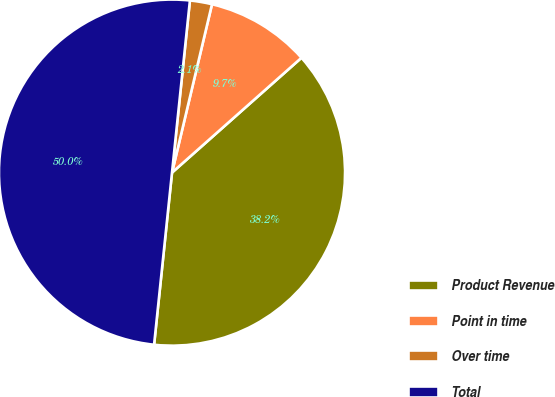Convert chart. <chart><loc_0><loc_0><loc_500><loc_500><pie_chart><fcel>Product Revenue<fcel>Point in time<fcel>Over time<fcel>Total<nl><fcel>38.2%<fcel>9.74%<fcel>2.06%<fcel>50.0%<nl></chart> 